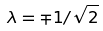<formula> <loc_0><loc_0><loc_500><loc_500>\lambda = \mp 1 / \sqrt { 2 }</formula> 